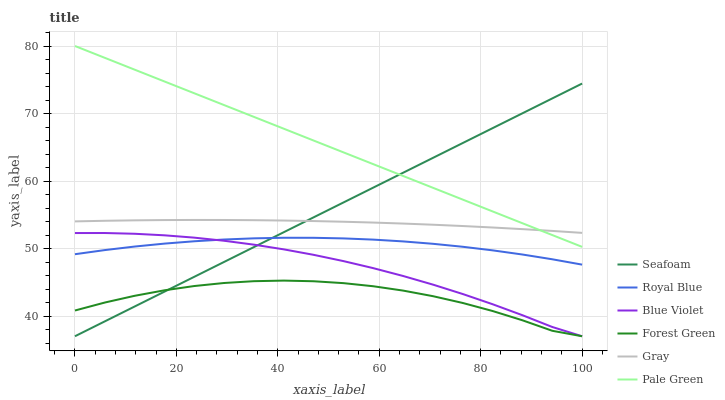Does Forest Green have the minimum area under the curve?
Answer yes or no. Yes. Does Pale Green have the maximum area under the curve?
Answer yes or no. Yes. Does Seafoam have the minimum area under the curve?
Answer yes or no. No. Does Seafoam have the maximum area under the curve?
Answer yes or no. No. Is Seafoam the smoothest?
Answer yes or no. Yes. Is Forest Green the roughest?
Answer yes or no. Yes. Is Royal Blue the smoothest?
Answer yes or no. No. Is Royal Blue the roughest?
Answer yes or no. No. Does Seafoam have the lowest value?
Answer yes or no. Yes. Does Royal Blue have the lowest value?
Answer yes or no. No. Does Pale Green have the highest value?
Answer yes or no. Yes. Does Seafoam have the highest value?
Answer yes or no. No. Is Blue Violet less than Pale Green?
Answer yes or no. Yes. Is Gray greater than Forest Green?
Answer yes or no. Yes. Does Blue Violet intersect Seafoam?
Answer yes or no. Yes. Is Blue Violet less than Seafoam?
Answer yes or no. No. Is Blue Violet greater than Seafoam?
Answer yes or no. No. Does Blue Violet intersect Pale Green?
Answer yes or no. No. 